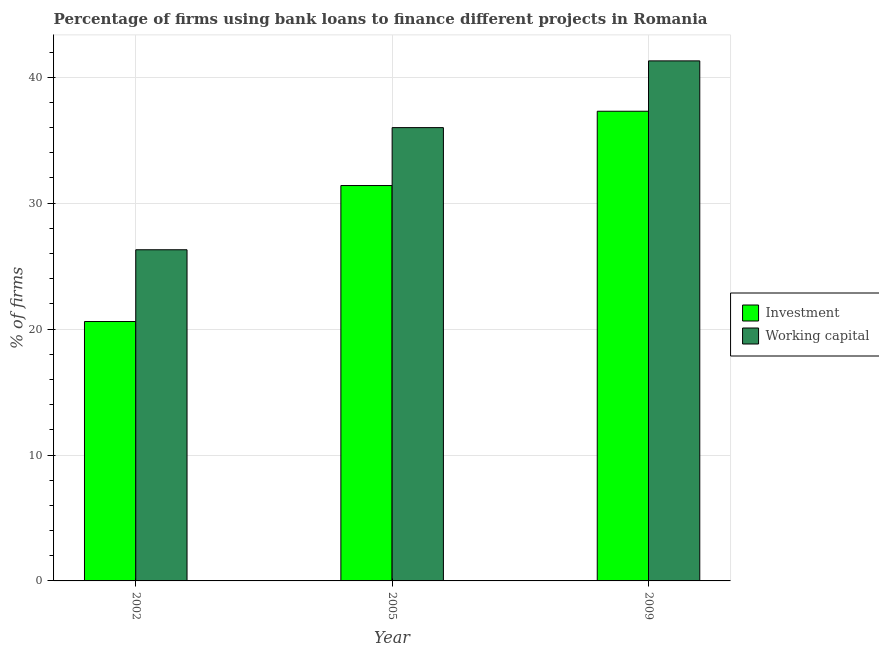How many different coloured bars are there?
Give a very brief answer. 2. Are the number of bars per tick equal to the number of legend labels?
Your response must be concise. Yes. Are the number of bars on each tick of the X-axis equal?
Offer a terse response. Yes. How many bars are there on the 1st tick from the right?
Keep it short and to the point. 2. What is the label of the 3rd group of bars from the left?
Give a very brief answer. 2009. What is the percentage of firms using banks to finance working capital in 2009?
Offer a very short reply. 41.3. Across all years, what is the maximum percentage of firms using banks to finance working capital?
Your response must be concise. 41.3. Across all years, what is the minimum percentage of firms using banks to finance investment?
Your response must be concise. 20.6. In which year was the percentage of firms using banks to finance investment maximum?
Provide a succinct answer. 2009. What is the total percentage of firms using banks to finance working capital in the graph?
Ensure brevity in your answer.  103.6. What is the difference between the percentage of firms using banks to finance investment in 2002 and that in 2009?
Your response must be concise. -16.7. What is the difference between the percentage of firms using banks to finance working capital in 2009 and the percentage of firms using banks to finance investment in 2005?
Your answer should be very brief. 5.3. What is the average percentage of firms using banks to finance working capital per year?
Offer a terse response. 34.53. In how many years, is the percentage of firms using banks to finance investment greater than 30 %?
Your response must be concise. 2. What is the ratio of the percentage of firms using banks to finance investment in 2002 to that in 2009?
Keep it short and to the point. 0.55. Is the percentage of firms using banks to finance working capital in 2002 less than that in 2005?
Offer a very short reply. Yes. Is the difference between the percentage of firms using banks to finance investment in 2005 and 2009 greater than the difference between the percentage of firms using banks to finance working capital in 2005 and 2009?
Your response must be concise. No. What is the difference between the highest and the second highest percentage of firms using banks to finance investment?
Ensure brevity in your answer.  5.9. What is the difference between the highest and the lowest percentage of firms using banks to finance working capital?
Your answer should be compact. 15. Is the sum of the percentage of firms using banks to finance working capital in 2005 and 2009 greater than the maximum percentage of firms using banks to finance investment across all years?
Ensure brevity in your answer.  Yes. What does the 2nd bar from the left in 2009 represents?
Your answer should be compact. Working capital. What does the 1st bar from the right in 2002 represents?
Provide a succinct answer. Working capital. How many years are there in the graph?
Provide a succinct answer. 3. What is the difference between two consecutive major ticks on the Y-axis?
Provide a succinct answer. 10. Does the graph contain any zero values?
Make the answer very short. No. Where does the legend appear in the graph?
Give a very brief answer. Center right. How many legend labels are there?
Provide a short and direct response. 2. What is the title of the graph?
Keep it short and to the point. Percentage of firms using bank loans to finance different projects in Romania. Does "Current US$" appear as one of the legend labels in the graph?
Your response must be concise. No. What is the label or title of the Y-axis?
Give a very brief answer. % of firms. What is the % of firms in Investment in 2002?
Give a very brief answer. 20.6. What is the % of firms in Working capital in 2002?
Provide a succinct answer. 26.3. What is the % of firms in Investment in 2005?
Make the answer very short. 31.4. What is the % of firms of Investment in 2009?
Offer a very short reply. 37.3. What is the % of firms of Working capital in 2009?
Your answer should be compact. 41.3. Across all years, what is the maximum % of firms in Investment?
Keep it short and to the point. 37.3. Across all years, what is the maximum % of firms in Working capital?
Your response must be concise. 41.3. Across all years, what is the minimum % of firms in Investment?
Give a very brief answer. 20.6. Across all years, what is the minimum % of firms of Working capital?
Keep it short and to the point. 26.3. What is the total % of firms of Investment in the graph?
Your answer should be very brief. 89.3. What is the total % of firms of Working capital in the graph?
Your answer should be very brief. 103.6. What is the difference between the % of firms of Working capital in 2002 and that in 2005?
Your answer should be very brief. -9.7. What is the difference between the % of firms of Investment in 2002 and that in 2009?
Your answer should be very brief. -16.7. What is the difference between the % of firms in Working capital in 2005 and that in 2009?
Make the answer very short. -5.3. What is the difference between the % of firms in Investment in 2002 and the % of firms in Working capital in 2005?
Give a very brief answer. -15.4. What is the difference between the % of firms in Investment in 2002 and the % of firms in Working capital in 2009?
Make the answer very short. -20.7. What is the average % of firms of Investment per year?
Offer a very short reply. 29.77. What is the average % of firms in Working capital per year?
Your answer should be compact. 34.53. In the year 2002, what is the difference between the % of firms in Investment and % of firms in Working capital?
Your answer should be very brief. -5.7. In the year 2005, what is the difference between the % of firms in Investment and % of firms in Working capital?
Make the answer very short. -4.6. What is the ratio of the % of firms in Investment in 2002 to that in 2005?
Make the answer very short. 0.66. What is the ratio of the % of firms of Working capital in 2002 to that in 2005?
Your answer should be compact. 0.73. What is the ratio of the % of firms of Investment in 2002 to that in 2009?
Keep it short and to the point. 0.55. What is the ratio of the % of firms in Working capital in 2002 to that in 2009?
Give a very brief answer. 0.64. What is the ratio of the % of firms in Investment in 2005 to that in 2009?
Make the answer very short. 0.84. What is the ratio of the % of firms in Working capital in 2005 to that in 2009?
Keep it short and to the point. 0.87. What is the difference between the highest and the second highest % of firms of Investment?
Make the answer very short. 5.9. 